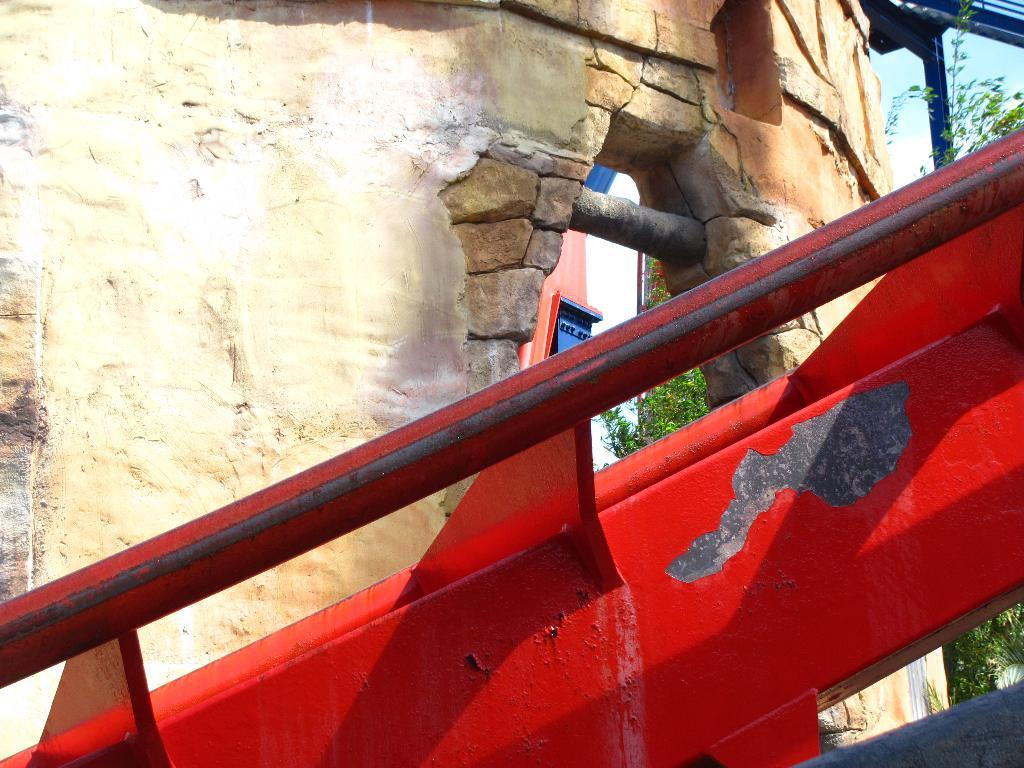What can be seen in the image? There is an object in the image. What is the object's location in relation to other elements in the image? The object is in front of a wall in the image. What can be seen in the background of the image? There is a tree and the sky visible in the background of the image. How does the object grip the tree in the image? The object does not grip the tree in the image, as there is no interaction between the object and the tree. 